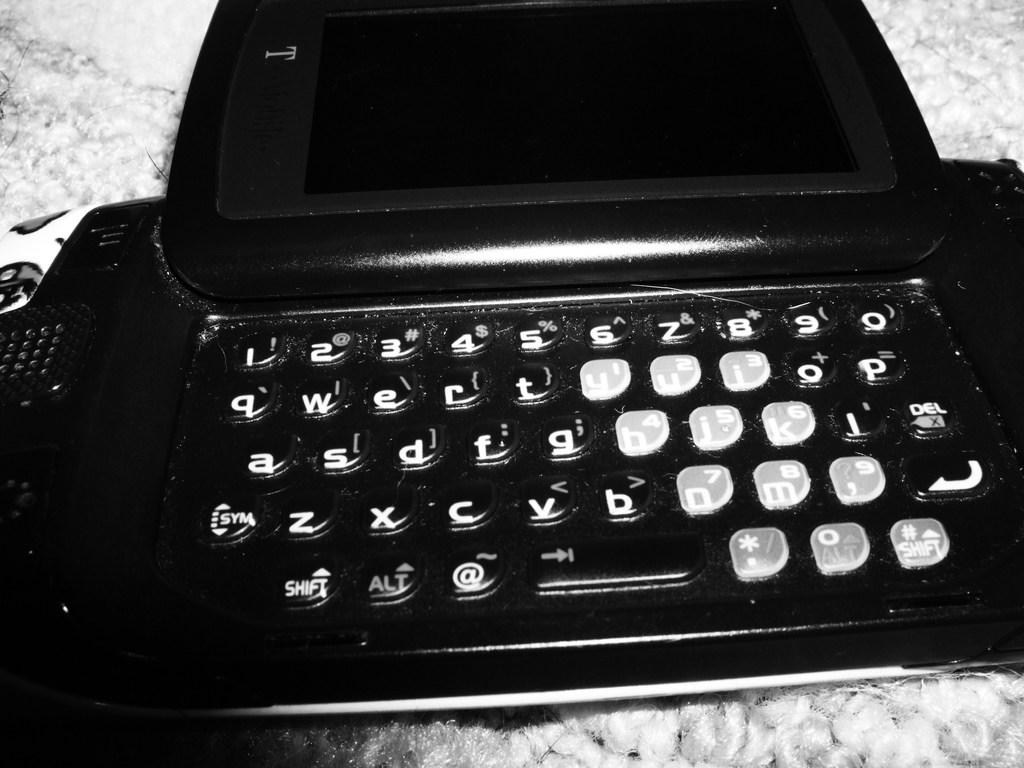What letters are directly under the numbers 1-5?
Your answer should be very brief. Qwert. 